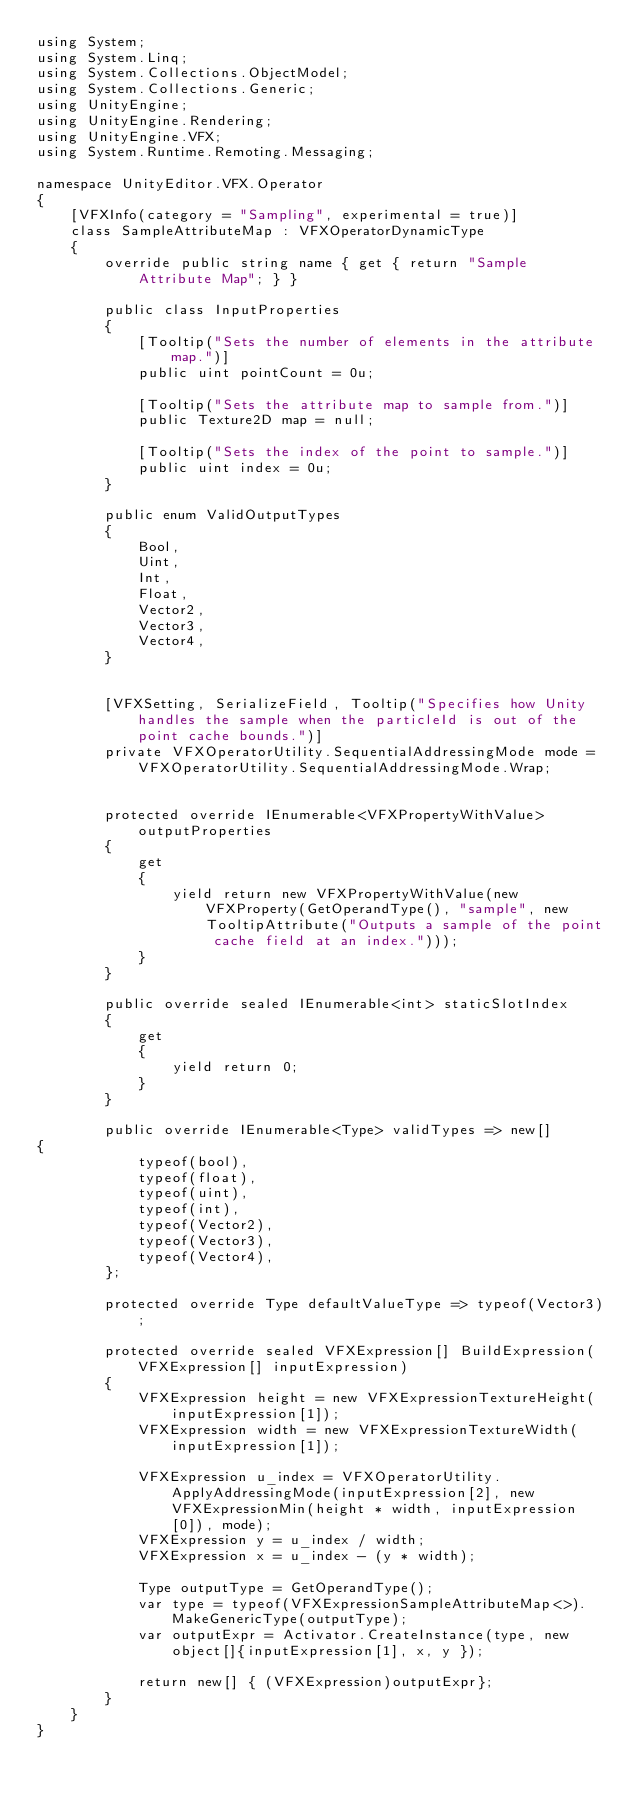<code> <loc_0><loc_0><loc_500><loc_500><_C#_>using System;
using System.Linq;
using System.Collections.ObjectModel;
using System.Collections.Generic;
using UnityEngine;
using UnityEngine.Rendering;
using UnityEngine.VFX;
using System.Runtime.Remoting.Messaging;

namespace UnityEditor.VFX.Operator
{
    [VFXInfo(category = "Sampling", experimental = true)]
    class SampleAttributeMap : VFXOperatorDynamicType
    {
        override public string name { get { return "Sample Attribute Map"; } }

        public class InputProperties
        {
            [Tooltip("Sets the number of elements in the attribute map.")]
            public uint pointCount = 0u;

            [Tooltip("Sets the attribute map to sample from.")]
            public Texture2D map = null;

            [Tooltip("Sets the index of the point to sample.")]
            public uint index = 0u;
        }

        public enum ValidOutputTypes
        {
            Bool,
            Uint,
            Int,
            Float,
            Vector2,
            Vector3,
            Vector4,
        }


        [VFXSetting, SerializeField, Tooltip("Specifies how Unity handles the sample when the particleId is out of the point cache bounds.")]
        private VFXOperatorUtility.SequentialAddressingMode mode = VFXOperatorUtility.SequentialAddressingMode.Wrap;


        protected override IEnumerable<VFXPropertyWithValue> outputProperties
        {
            get
            {
                yield return new VFXPropertyWithValue(new VFXProperty(GetOperandType(), "sample", new TooltipAttribute("Outputs a sample of the point cache field at an index.")));
            }
        }

        public override sealed IEnumerable<int> staticSlotIndex
        {
            get
            {
                yield return 0;
            }
        }

        public override IEnumerable<Type> validTypes => new[]
{
            typeof(bool),
            typeof(float),
            typeof(uint),
            typeof(int),
            typeof(Vector2),
            typeof(Vector3),
            typeof(Vector4),
        };

        protected override Type defaultValueType => typeof(Vector3);

        protected override sealed VFXExpression[] BuildExpression(VFXExpression[] inputExpression)
        {
            VFXExpression height = new VFXExpressionTextureHeight(inputExpression[1]);
            VFXExpression width = new VFXExpressionTextureWidth(inputExpression[1]);

            VFXExpression u_index = VFXOperatorUtility.ApplyAddressingMode(inputExpression[2], new VFXExpressionMin(height * width, inputExpression[0]), mode);
            VFXExpression y = u_index / width;
            VFXExpression x = u_index - (y * width);

            Type outputType = GetOperandType();
            var type = typeof(VFXExpressionSampleAttributeMap<>).MakeGenericType(outputType);
            var outputExpr = Activator.CreateInstance(type, new object[]{inputExpression[1], x, y });

            return new[] { (VFXExpression)outputExpr};
        }
    }
}
</code> 